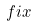Convert formula to latex. <formula><loc_0><loc_0><loc_500><loc_500>f i x</formula> 